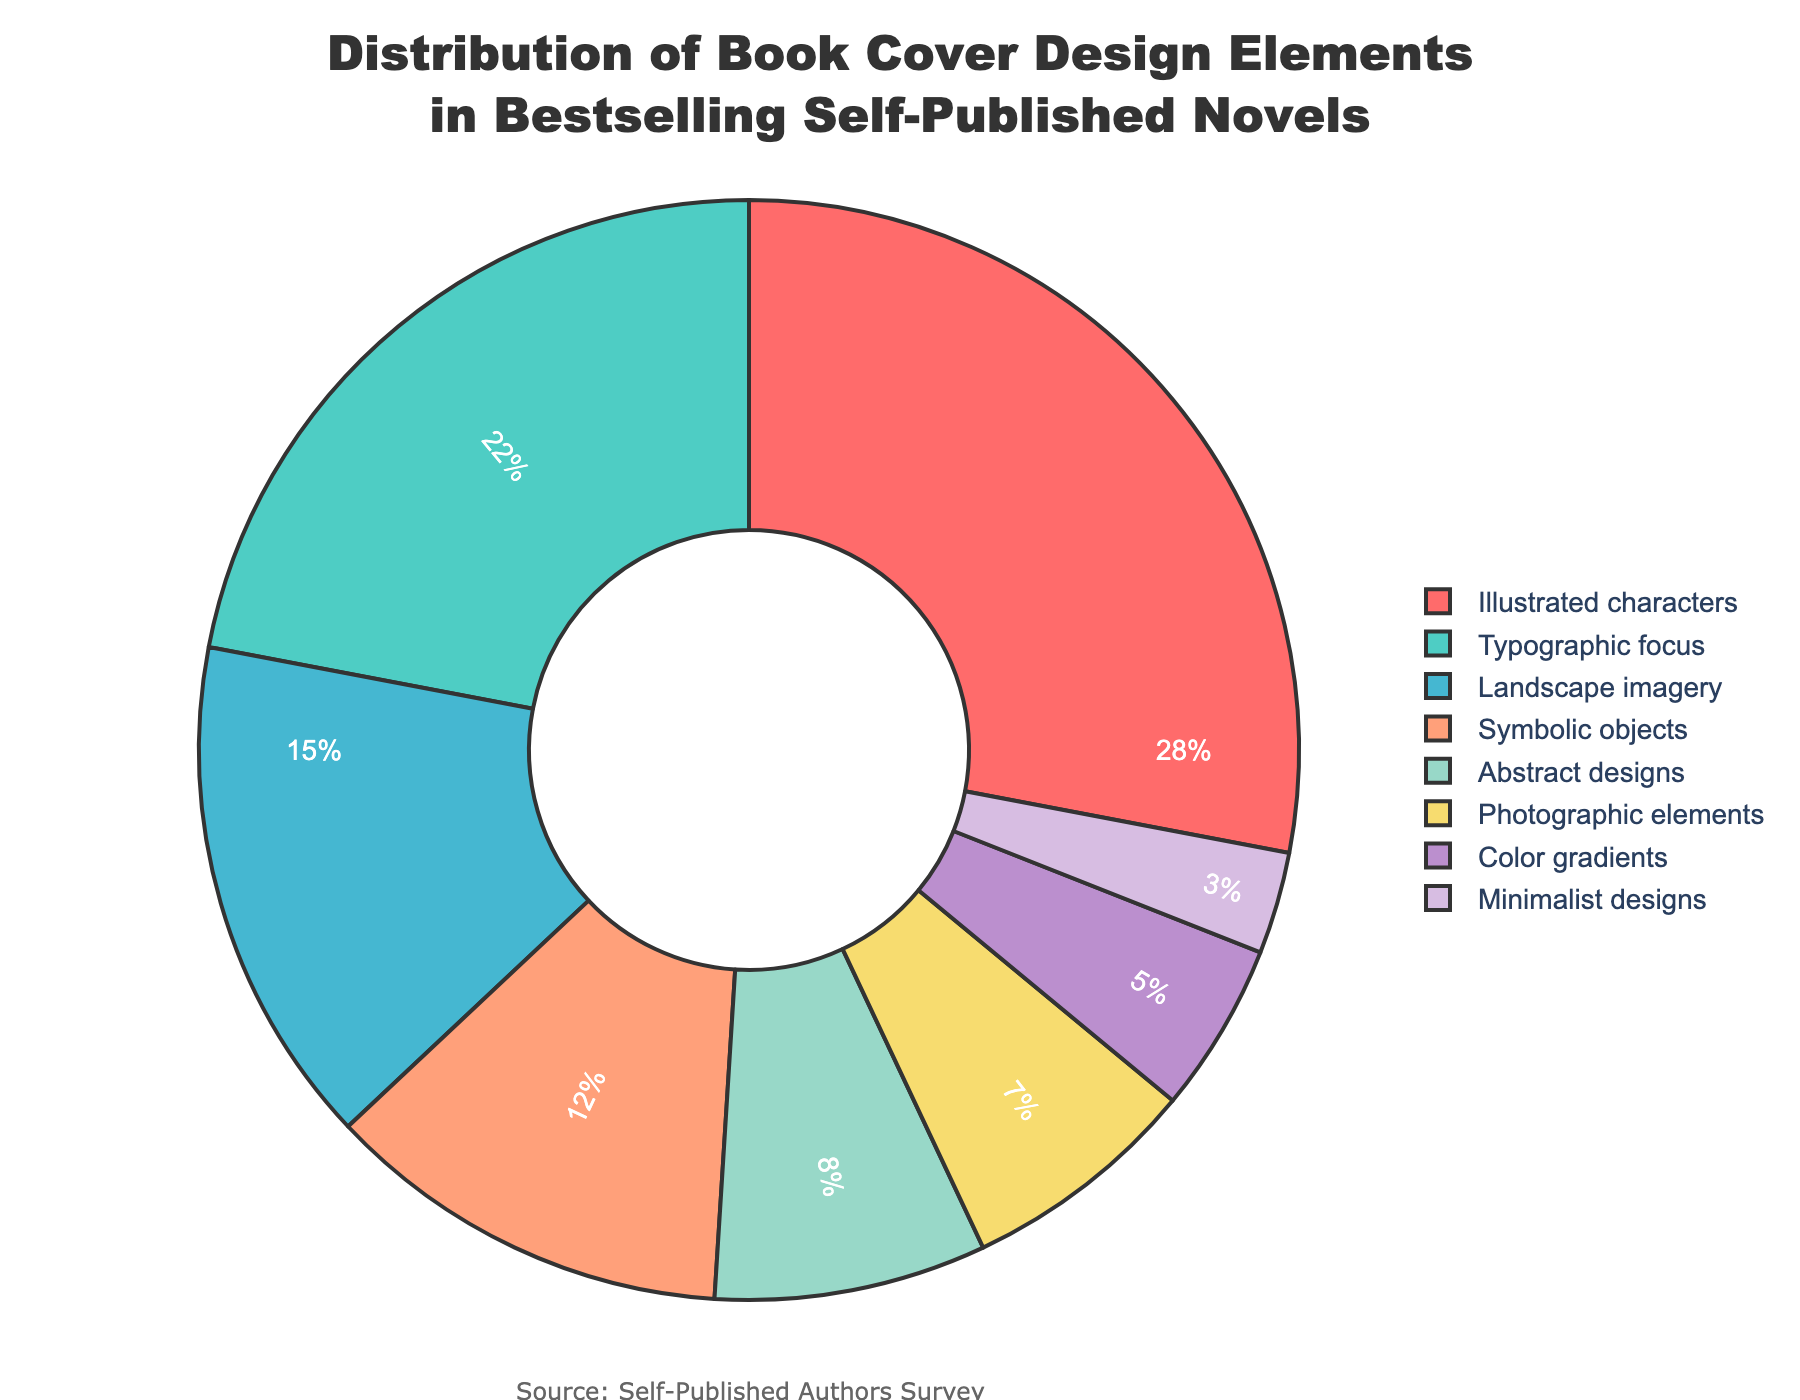What is the most common design element used in bestselling self-published novels? The pie chart shows that "Illustrated characters" has the largest percentage among all the design elements.
Answer: Illustrated characters What percentage of book covers feature symbolic objects and color gradients combined? Sum the percentages of "Symbolic objects" (12%) and "Color gradients" (5%) from the pie chart.
Answer: 17% Which design element has a higher percentage, landscape imagery or abstract designs? Compare the percentages of "Landscape imagery" (15%) and "Abstract designs" (8%) in the pie chart.
Answer: Landscape imagery What is the total percentage of book covers that use either photographic elements or minimalist designs? Sum the percentages of "Photographic elements" (7%) and "Minimalist designs" (3%).
Answer: 10% What is the difference in percentage between illustrated characters and typographic focus? Subtract the percentage of "Typographic focus" (22%) from the percentage of "Illustrated characters" (28%).
Answer: 6% How does the percentage of book covers with landscape imagery compare to those with symbolic objects? The percentage for "Landscape imagery" is 15%, whereas for "Symbolic objects" it is 12%.
Answer: Landscape imagery is higher Which segment is colored green and what is its corresponding percentage? The color green is assigned to "Typographic focus" which has a percentage of 22% according to the color mapping and the pie chart.
Answer: Typographic focus; 22% What is the cumulative percentage for categories with less than 10% representation? Sum the percentages of "Abstract designs" (8%), "Photographic elements" (7%), "Color gradients" (5%), and "Minimalist designs" (3%).
Answer: 23% If we group symbolic objects and abstract designs together, what would their combined percentage be? Add the percentages of "Symbolic objects" (12%) and "Abstract designs" (8%).
Answer: 20% Which design element has the lowest percentage, and what is it? The pie chart shows "Minimalist designs" has the smallest percentage at 3%.
Answer: Minimalist designs; 3% 